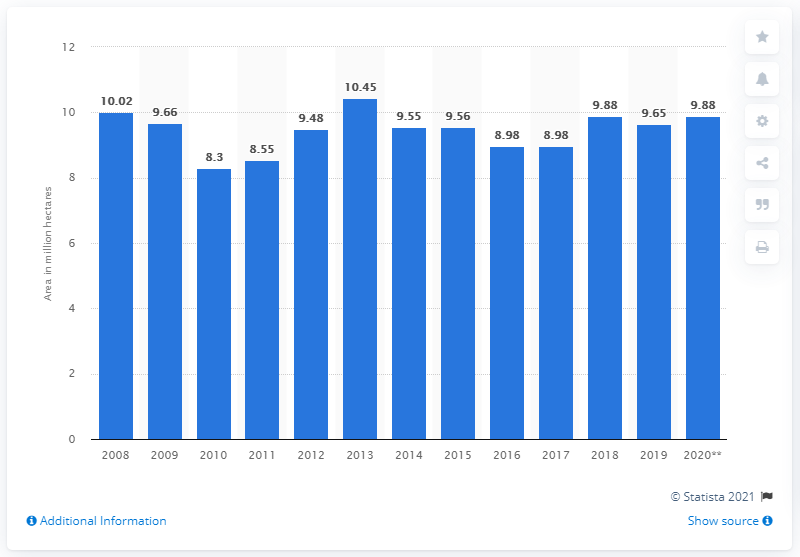Highlight a few significant elements in this photo. In 2019, Canada harvested a total of 9.65 million metric tons of wheat. 